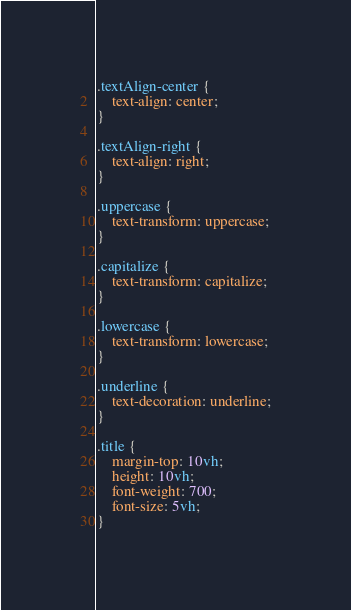Convert code to text. <code><loc_0><loc_0><loc_500><loc_500><_CSS_>.textAlign-center {
    text-align: center;
}

.textAlign-right {
    text-align: right;
}

.uppercase {
    text-transform: uppercase;
}

.capitalize {
    text-transform: capitalize;
}

.lowercase {
    text-transform: lowercase;
}

.underline {
    text-decoration: underline;
}

.title {
    margin-top: 10vh;
    height: 10vh;
    font-weight: 700;
    font-size: 5vh;
}</code> 